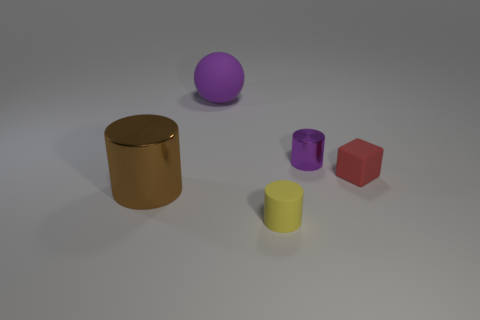Subtract all brown shiny cylinders. How many cylinders are left? 2 Add 4 tiny purple things. How many objects exist? 9 Subtract 2 cylinders. How many cylinders are left? 1 Subtract all blocks. How many objects are left? 4 Subtract all brown cylinders. Subtract all green cubes. How many cylinders are left? 2 Subtract all brown cylinders. Subtract all small purple shiny objects. How many objects are left? 3 Add 4 purple cylinders. How many purple cylinders are left? 5 Add 4 large blue objects. How many large blue objects exist? 4 Subtract all brown cylinders. How many cylinders are left? 2 Subtract 1 red cubes. How many objects are left? 4 